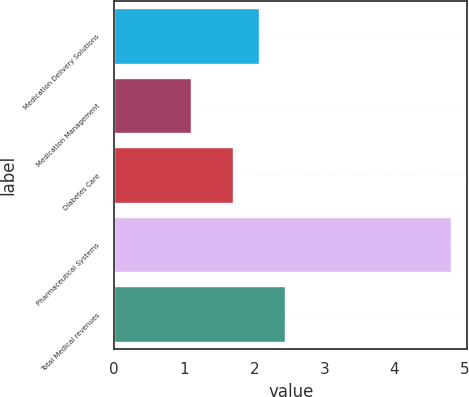<chart> <loc_0><loc_0><loc_500><loc_500><bar_chart><fcel>Medication Delivery Solutions<fcel>Medication Management<fcel>Diabetes Care<fcel>Pharmaceutical Systems<fcel>Total Medical revenues<nl><fcel>2.07<fcel>1.1<fcel>1.7<fcel>4.8<fcel>2.44<nl></chart> 